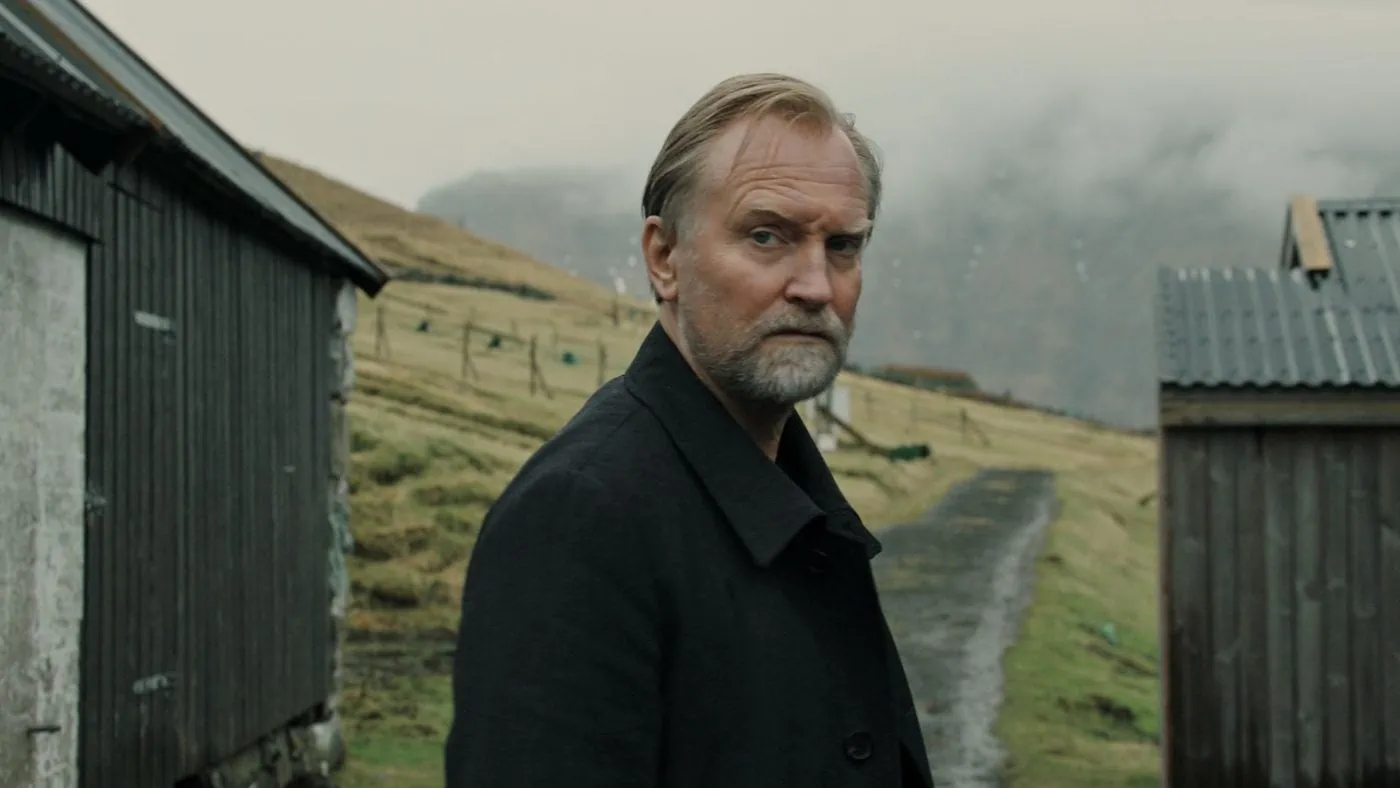If this image were part of a movie, what genre would it be and what would the plot entail? If this image were part of a movie, it would likely belong to the drama genre, possibly with elements of mystery. The plot could revolve around the protagonist, a man who returns to his rural hometown after many years to uncover secrets about his past. The serene yet somber setting would provide a backdrop for a story rich with emotional depth and introspective moments. As he reconnects with old acquaintances and the remnants of his childhood, he might uncover hidden truths about his family's history, face unresolved conflicts, and ultimately find closure or redemption. The film would explore themes of memory, loss, and the inescapable passage of time. 